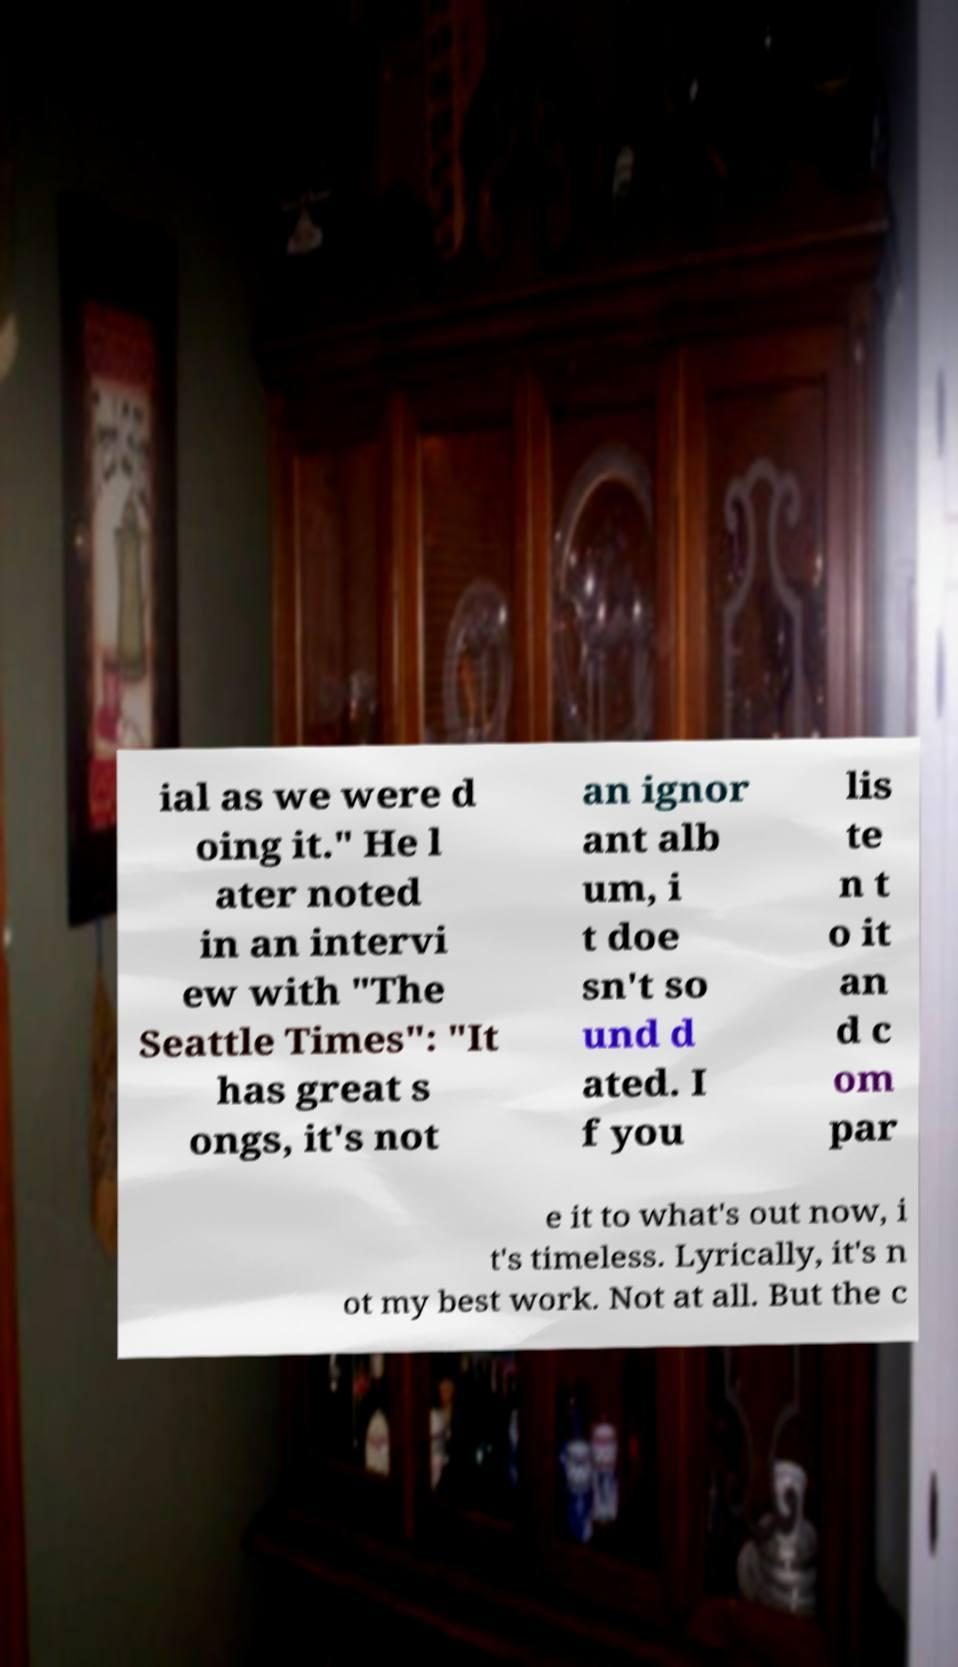What messages or text are displayed in this image? I need them in a readable, typed format. ial as we were d oing it." He l ater noted in an intervi ew with "The Seattle Times": "It has great s ongs, it's not an ignor ant alb um, i t doe sn't so und d ated. I f you lis te n t o it an d c om par e it to what's out now, i t's timeless. Lyrically, it's n ot my best work. Not at all. But the c 